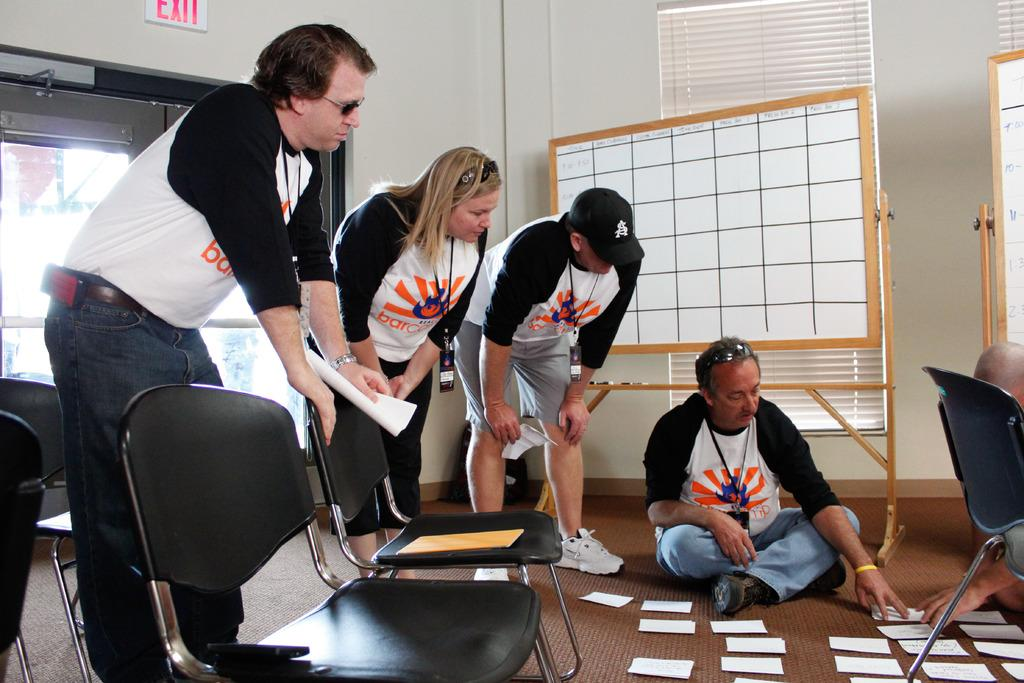What is the color of the wall in the image? The wall in the image is white. What can be seen on the wall in the image? There is a window on the wall in the image. What type of furniture is present in the image? There are chairs in the image. Who or what is present in the image? There are people in the image. What else can be seen in the image besides the wall, window, chairs, and people? There are boards and papers on the floor in the image. How many birds are sitting on the guitar in the image? There is no guitar or birds present in the image. 